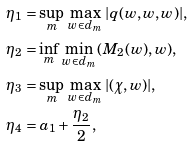<formula> <loc_0><loc_0><loc_500><loc_500>& \eta _ { 1 } = \sup _ { m } \, \max _ { w \in d _ { m } } \, | q ( w , w , w ) | , \\ & \eta _ { 2 } = \inf _ { m } \, \min _ { w \in d _ { m } } \, ( M _ { 2 } ( w ) , w ) , \\ & \eta _ { 3 } = \sup _ { m } \, \max _ { w \in d _ { m } } \, | ( \chi , w ) | , \\ & \eta _ { 4 } = a _ { 1 } + \frac { \eta _ { 2 } } 2 ,</formula> 